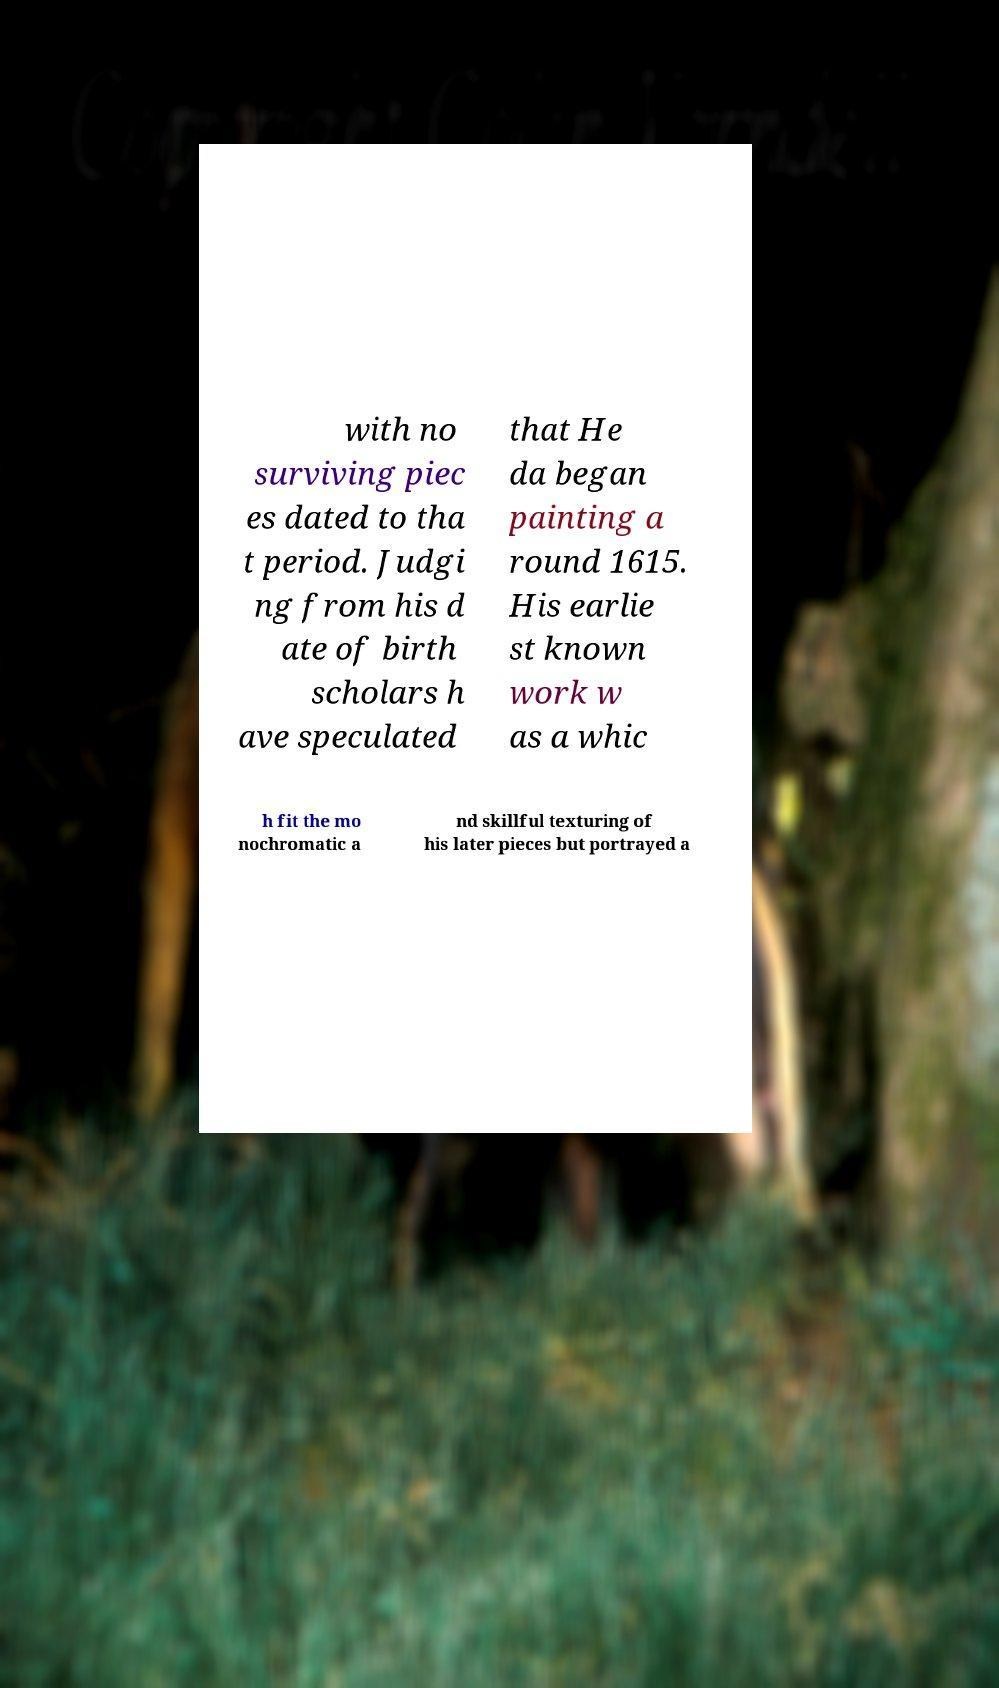Can you accurately transcribe the text from the provided image for me? with no surviving piec es dated to tha t period. Judgi ng from his d ate of birth scholars h ave speculated that He da began painting a round 1615. His earlie st known work w as a whic h fit the mo nochromatic a nd skillful texturing of his later pieces but portrayed a 